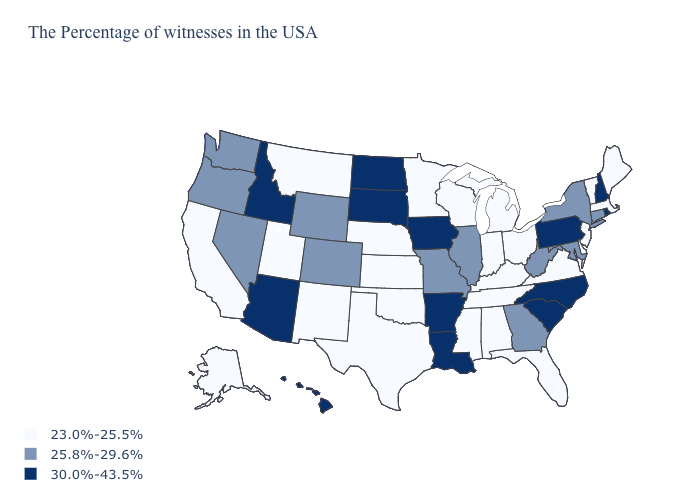What is the value of Maryland?
Give a very brief answer. 25.8%-29.6%. What is the highest value in the USA?
Short answer required. 30.0%-43.5%. Among the states that border Delaware , does Pennsylvania have the highest value?
Be succinct. Yes. Does Oklahoma have a lower value than Oregon?
Quick response, please. Yes. Name the states that have a value in the range 25.8%-29.6%?
Quick response, please. Connecticut, New York, Maryland, West Virginia, Georgia, Illinois, Missouri, Wyoming, Colorado, Nevada, Washington, Oregon. What is the lowest value in the USA?
Short answer required. 23.0%-25.5%. Does the map have missing data?
Short answer required. No. What is the highest value in the USA?
Keep it brief. 30.0%-43.5%. Does the map have missing data?
Quick response, please. No. Name the states that have a value in the range 23.0%-25.5%?
Write a very short answer. Maine, Massachusetts, Vermont, New Jersey, Delaware, Virginia, Ohio, Florida, Michigan, Kentucky, Indiana, Alabama, Tennessee, Wisconsin, Mississippi, Minnesota, Kansas, Nebraska, Oklahoma, Texas, New Mexico, Utah, Montana, California, Alaska. Name the states that have a value in the range 23.0%-25.5%?
Quick response, please. Maine, Massachusetts, Vermont, New Jersey, Delaware, Virginia, Ohio, Florida, Michigan, Kentucky, Indiana, Alabama, Tennessee, Wisconsin, Mississippi, Minnesota, Kansas, Nebraska, Oklahoma, Texas, New Mexico, Utah, Montana, California, Alaska. What is the value of Nevada?
Give a very brief answer. 25.8%-29.6%. Does Indiana have a higher value than Iowa?
Short answer required. No. What is the value of New York?
Be succinct. 25.8%-29.6%. 